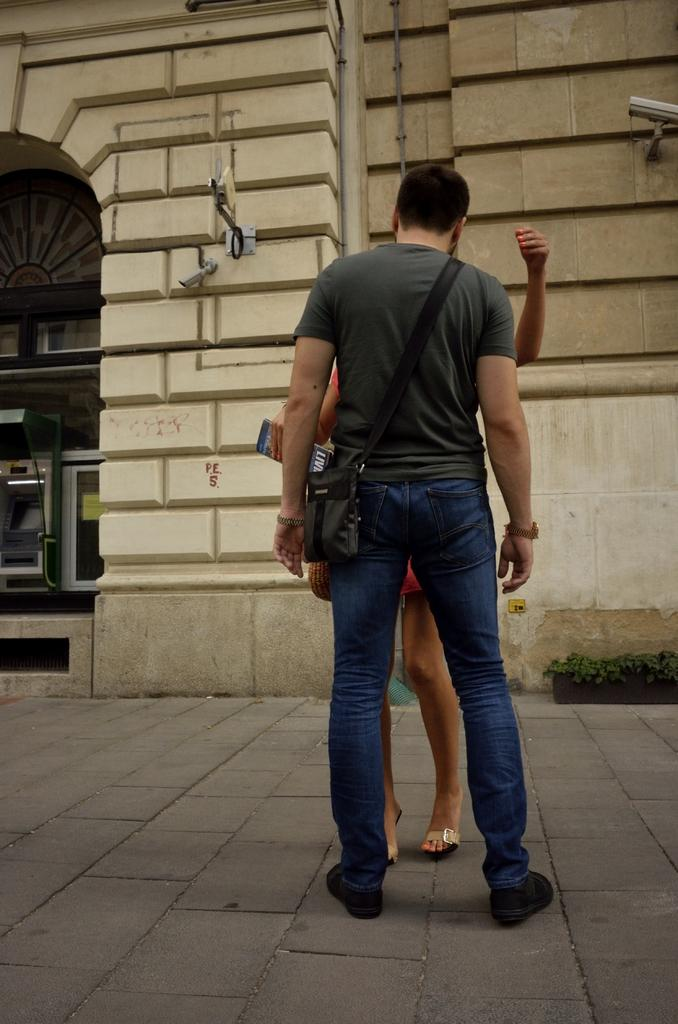How many people are in the image? There are two people standing in the front of the image. What is one of the people wearing? One of the people is wearing a bag. What can be seen in the background of the image? There is a wall and a plant in the background of the image. Are there any other objects or features visible in the background? Yes, there are other things visible in the background of the image. What type of fire can be seen in the image? There is no fire present in the image. What is the selection process for the bag the person is wearing? The provided facts do not give us any information about the selection process for the bag the person is wearing. 